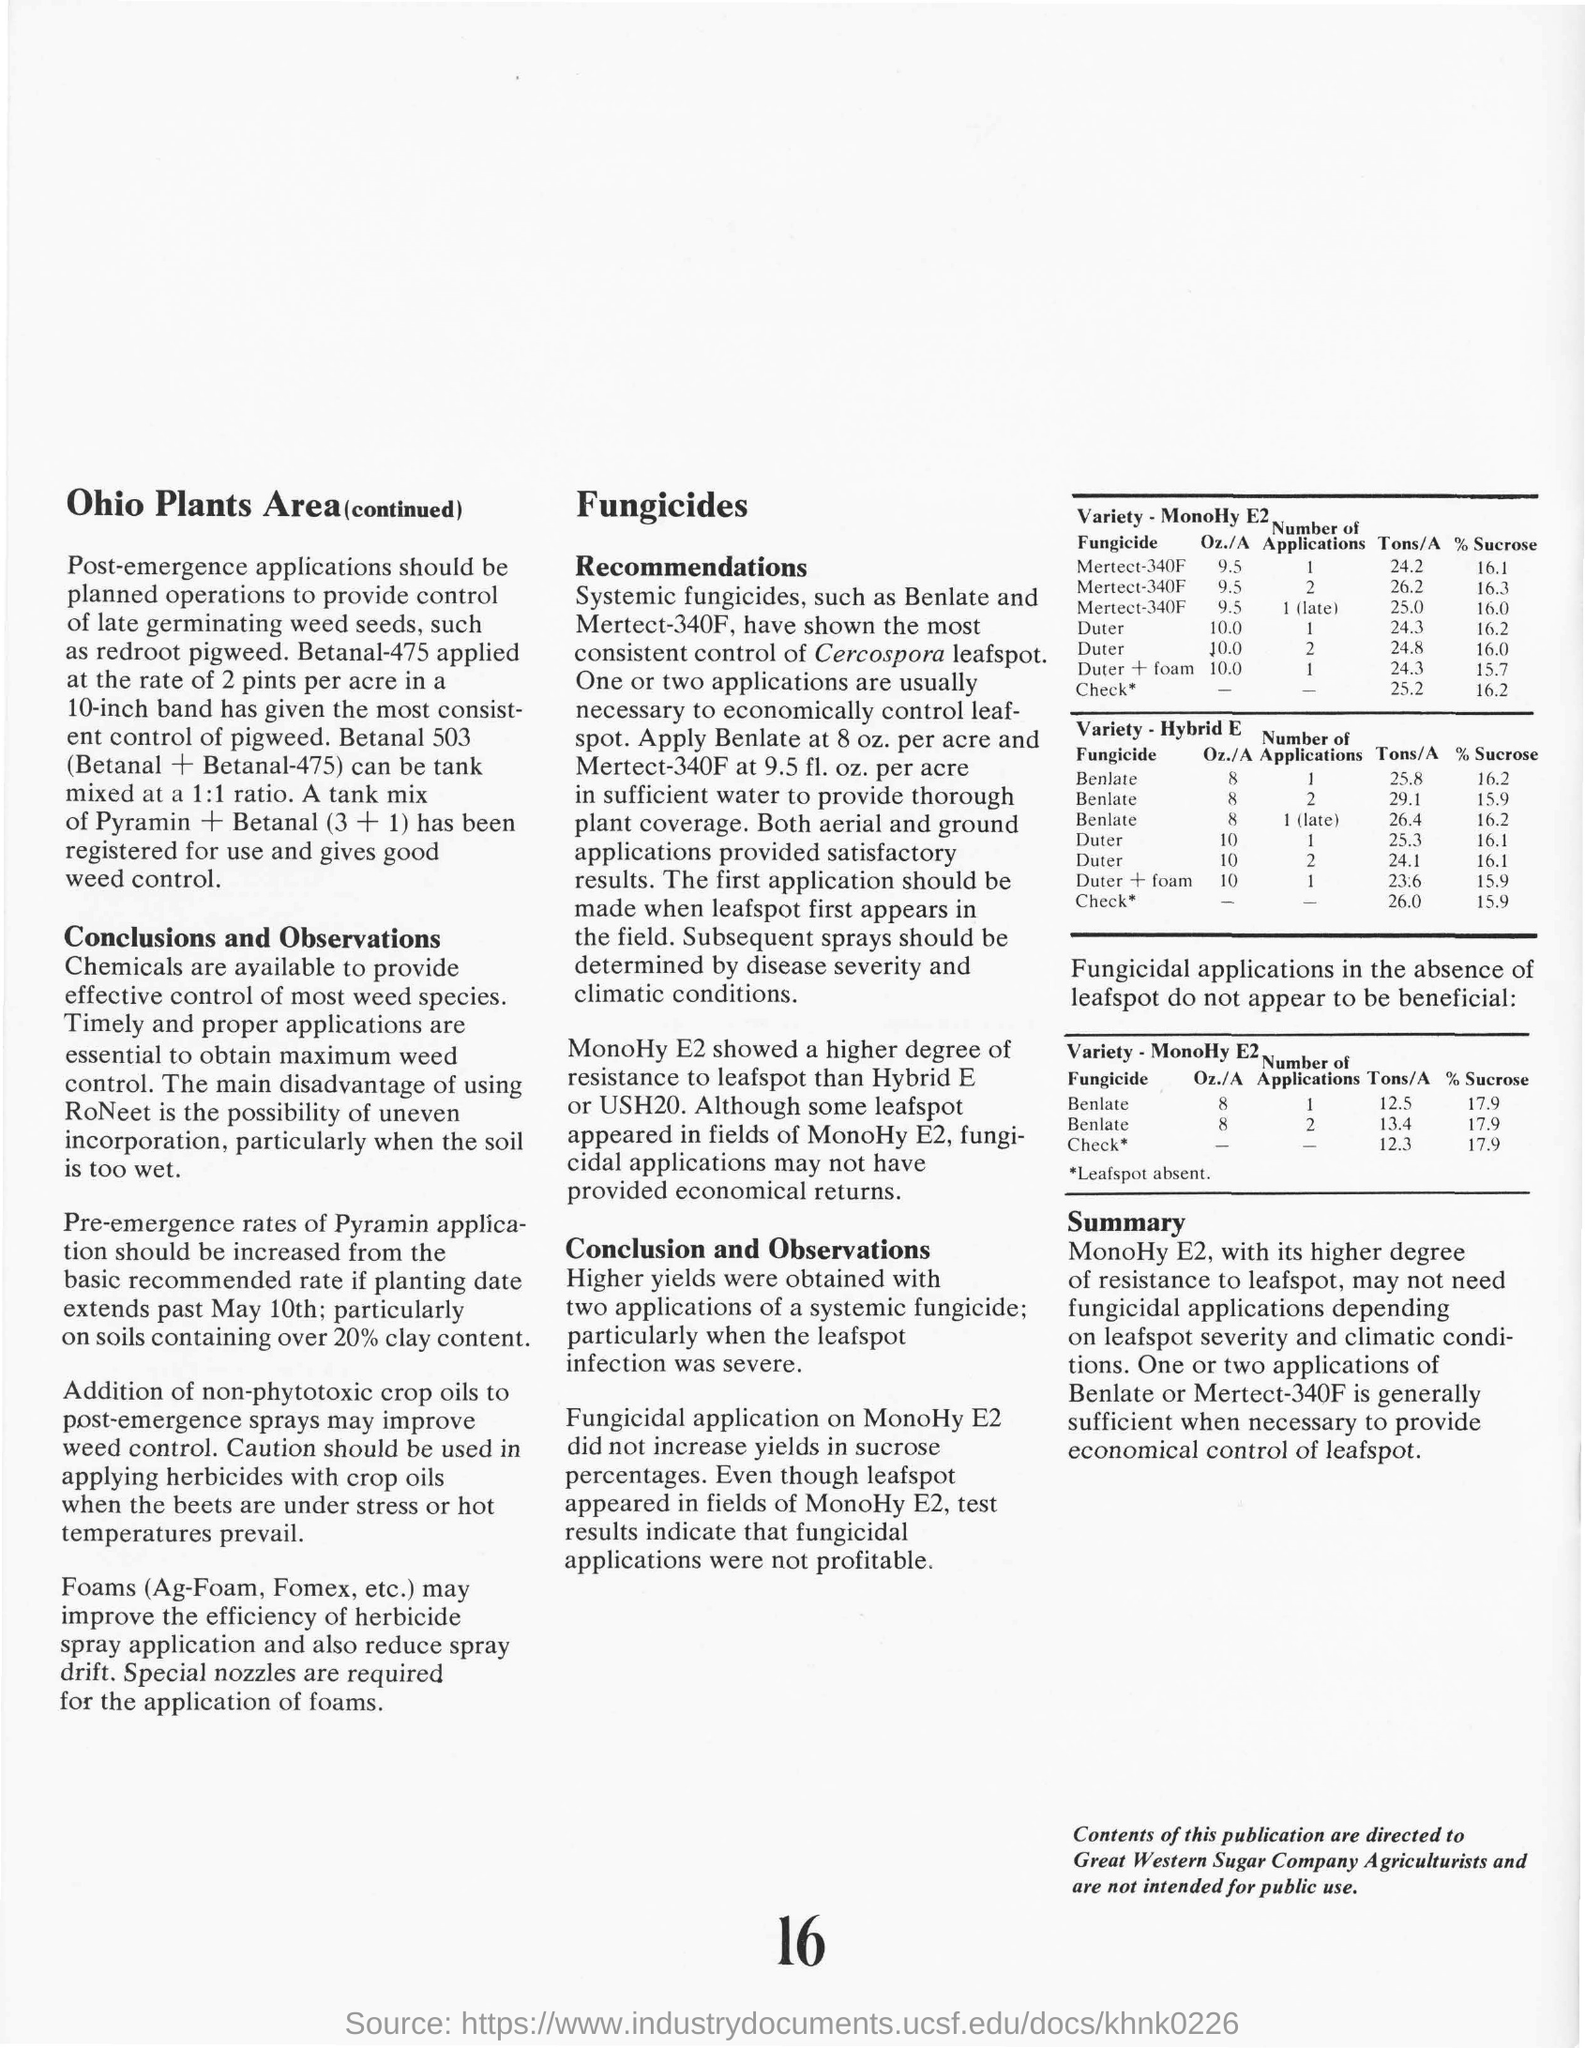Mention a couple of crucial points in this snapshot. Betanal and Betanal-475 have been formulated for tank mixing at a 1:1 ratio for optimal pesticide performance. The application of Duter twice at a rate of 10 ounces per acre on MonoHy E2 variety resulted in a yield of 24.8 tons per acre, and the sucrose content was X%. A study has shown that the most effective fungicides in controlling Cercospora leafspot are Benlate and Mertect-340F, with consistent results observed in both field and laboratory experiments. In the category of late germinating weed seeds, one can find Redroot pigweed. 